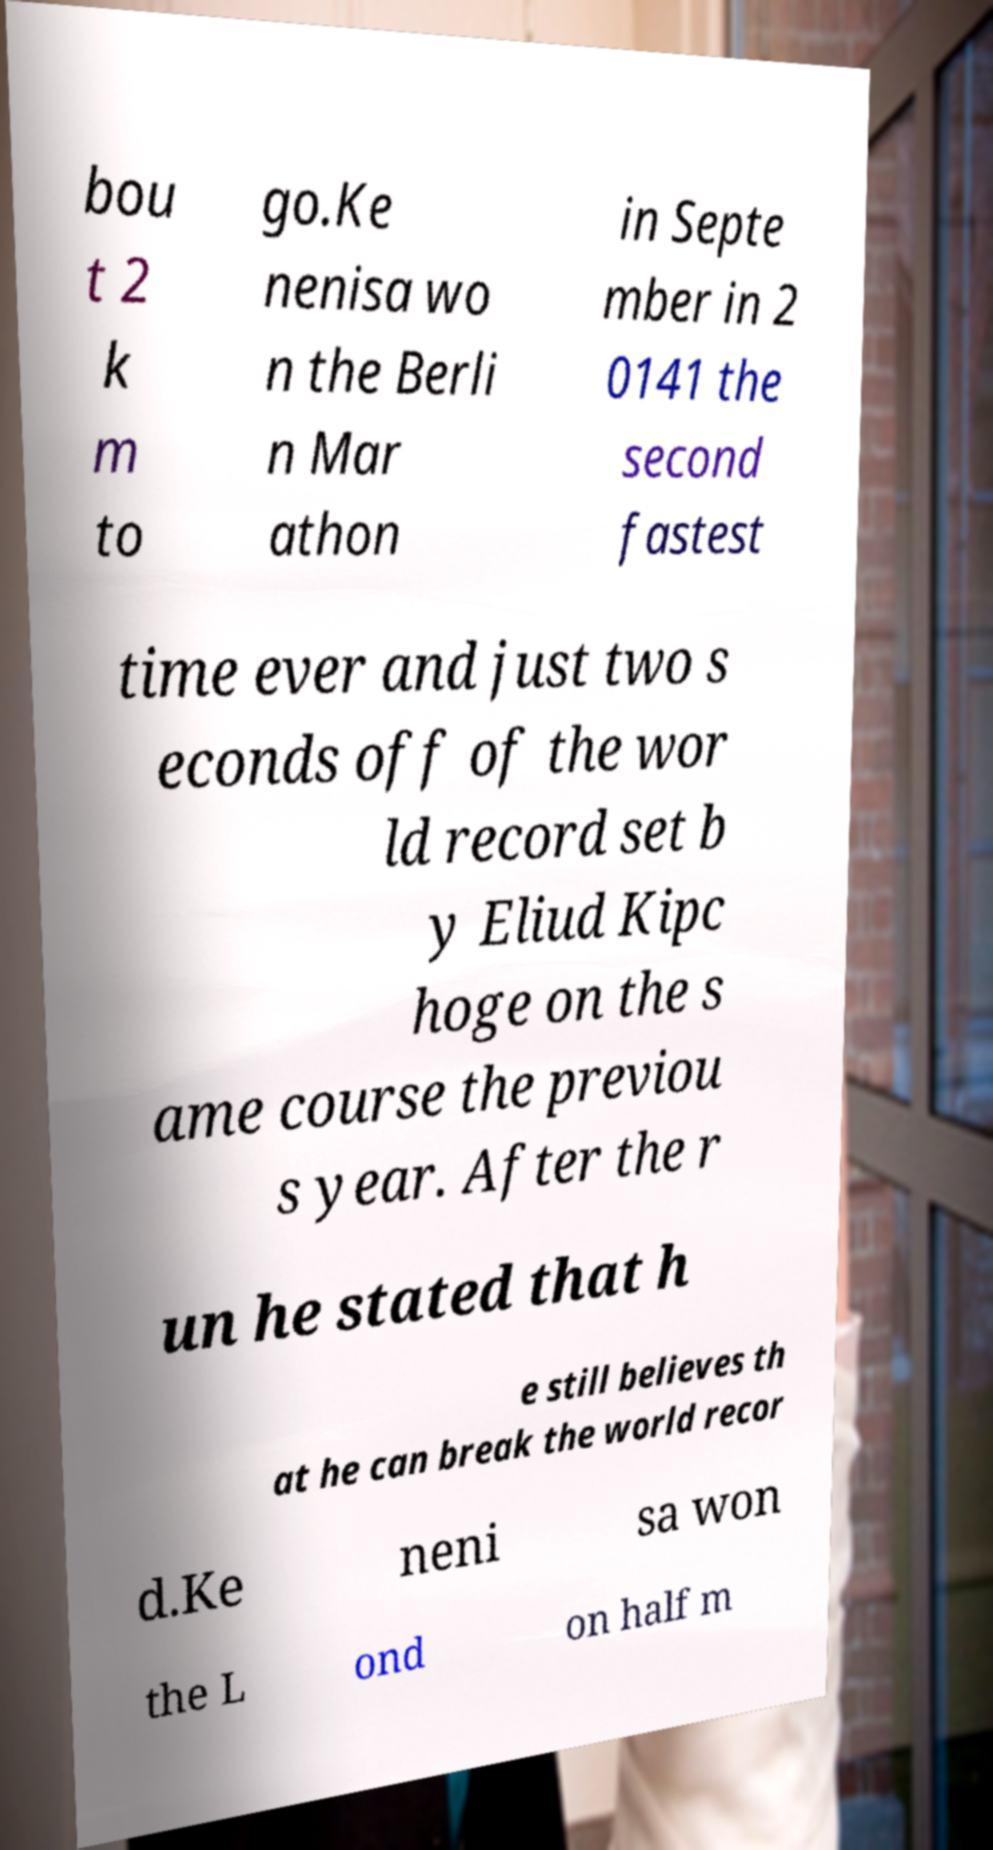Could you extract and type out the text from this image? bou t 2 k m to go.Ke nenisa wo n the Berli n Mar athon in Septe mber in 2 0141 the second fastest time ever and just two s econds off of the wor ld record set b y Eliud Kipc hoge on the s ame course the previou s year. After the r un he stated that h e still believes th at he can break the world recor d.Ke neni sa won the L ond on half m 